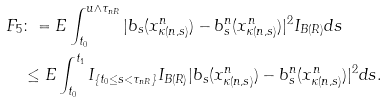Convert formula to latex. <formula><loc_0><loc_0><loc_500><loc_500>F _ { 5 } & \colon = E \int _ { t _ { 0 } } ^ { u \wedge \tau _ { n R } } | b _ { s } ( x ^ { n } _ { \kappa ( n , s ) } ) - b ^ { n } _ { s } ( x ^ { n } _ { \kappa ( n , s ) } ) | ^ { 2 } I _ { B ( R ) } d s \\ & \leq E \int _ { t _ { 0 } } ^ { t _ { 1 } } I _ { \{ t _ { 0 } \leq s < \tau _ { n R } \} } I _ { B ( R ) } | b _ { s } ( x ^ { n } _ { \kappa ( n , s ) } ) - b ^ { n } _ { s } ( x ^ { n } _ { \kappa ( n , s ) } ) | ^ { 2 } d s .</formula> 